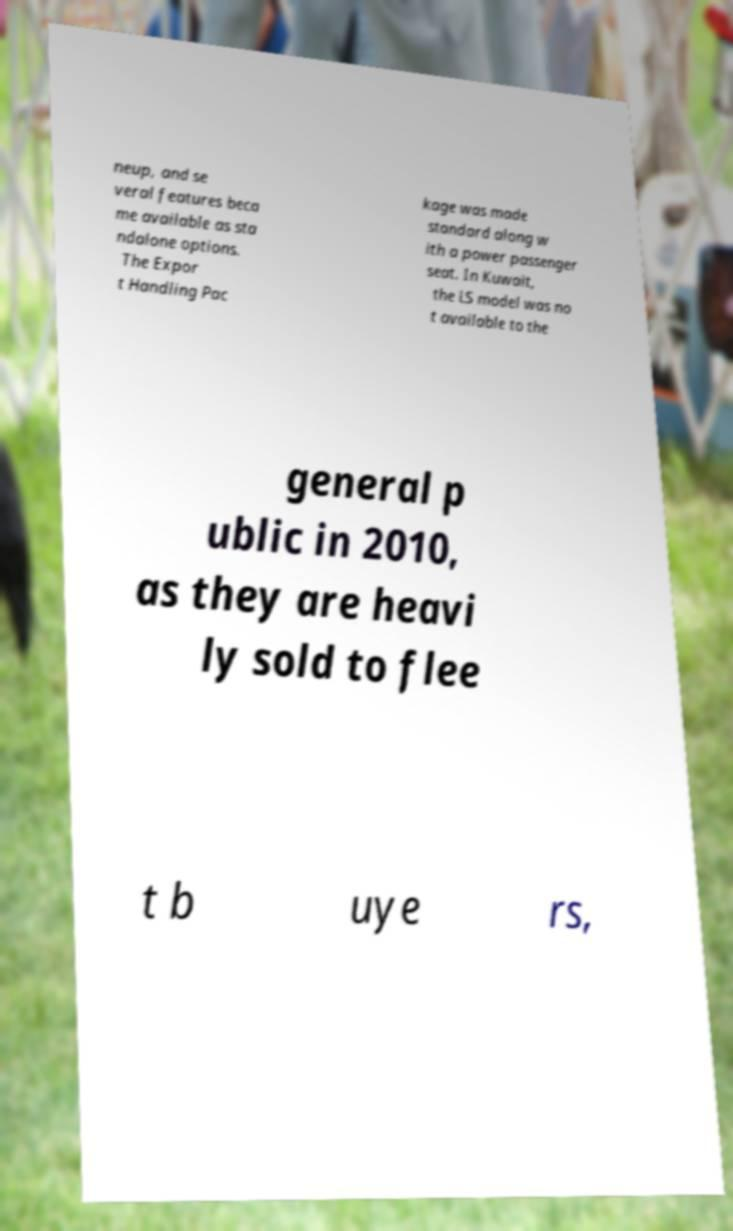I need the written content from this picture converted into text. Can you do that? neup, and se veral features beca me available as sta ndalone options. The Expor t Handling Pac kage was made standard along w ith a power passenger seat. In Kuwait, the LS model was no t available to the general p ublic in 2010, as they are heavi ly sold to flee t b uye rs, 